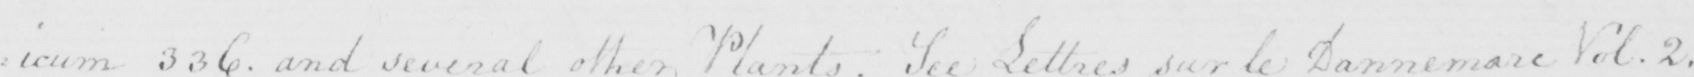Transcribe the text shown in this historical manuscript line. : icum 336 . and several other Plants . See Lettres sur le Dannemarc Vol . 2 . 